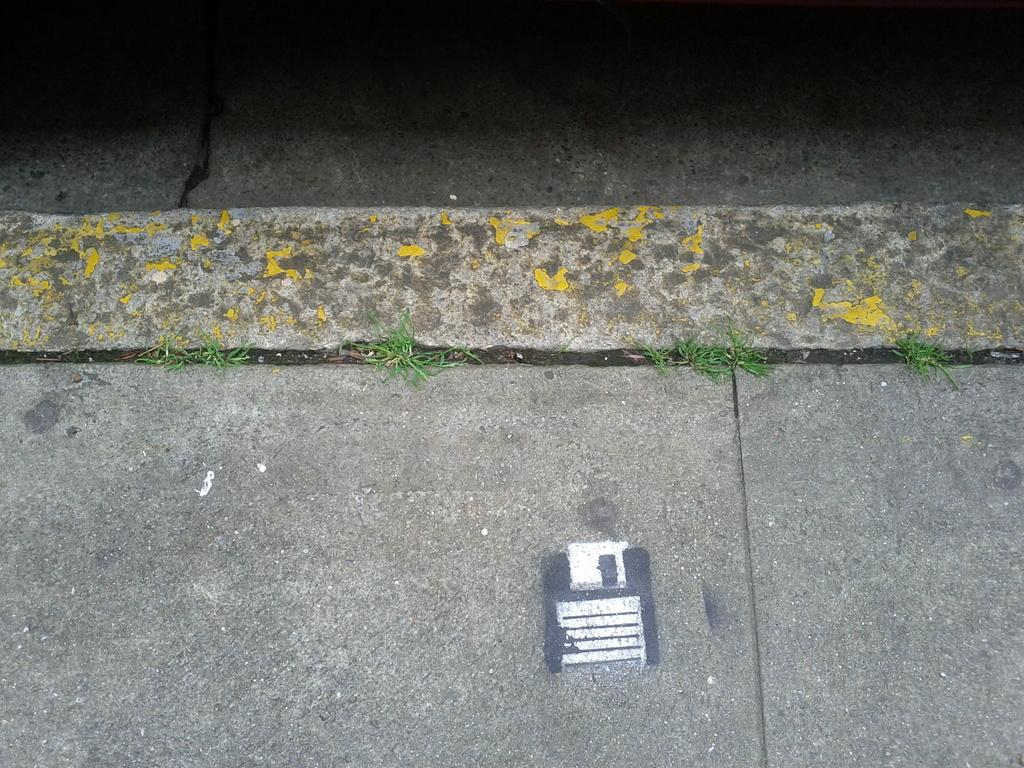What is the main feature of the image? There is a road in the image. Can you see the person wearing a veil walking on the road in the image? There is no person wearing a veil or any other individuals visible in the image; it only features a road. 